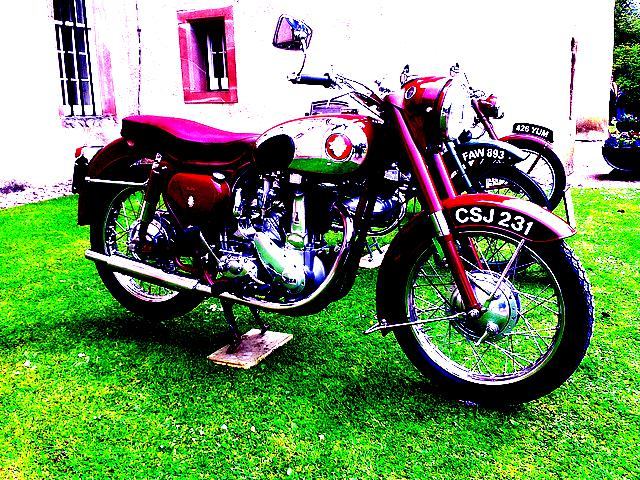Is the lighting in the image evenly distributed? The lighting in the image appears focused on the motorcycle, creating vivid highlights on its metal parts and casting diffused shadows on the grass, suggesting that the lighting is slightly uneven and possibly natural. 